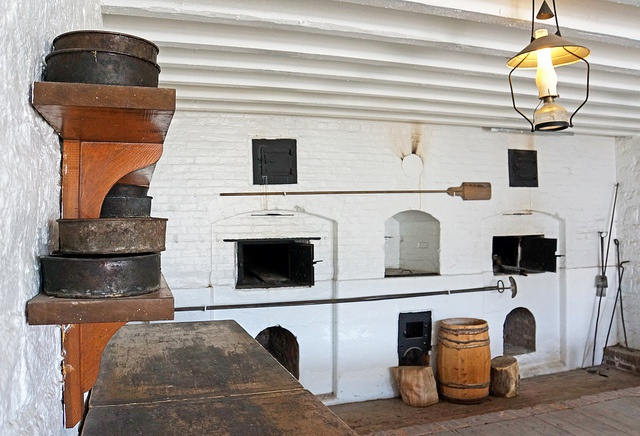Describe the objects in this image and their specific colors. I can see oven in lightgray, black, darkgray, and gray tones and oven in lightgray, black, and darkgray tones in this image. 